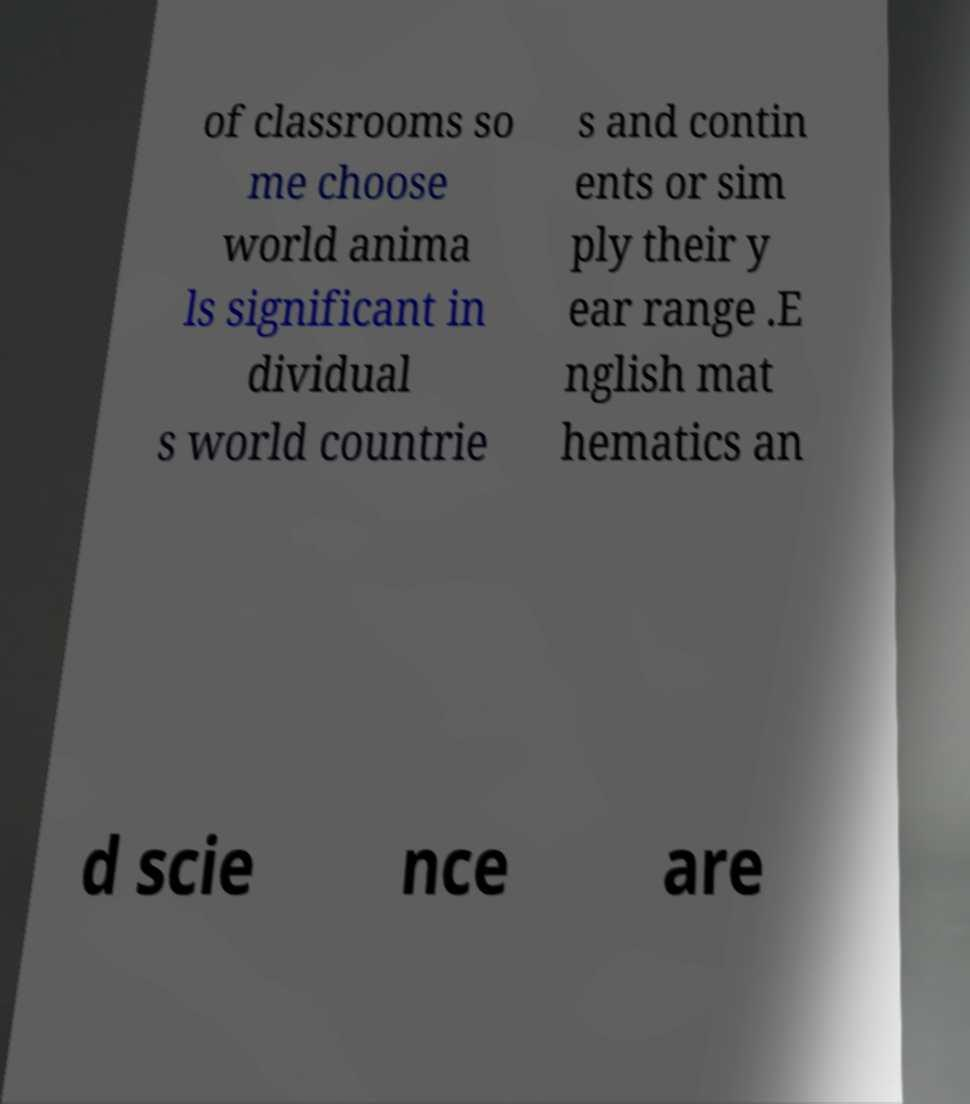Can you read and provide the text displayed in the image?This photo seems to have some interesting text. Can you extract and type it out for me? of classrooms so me choose world anima ls significant in dividual s world countrie s and contin ents or sim ply their y ear range .E nglish mat hematics an d scie nce are 